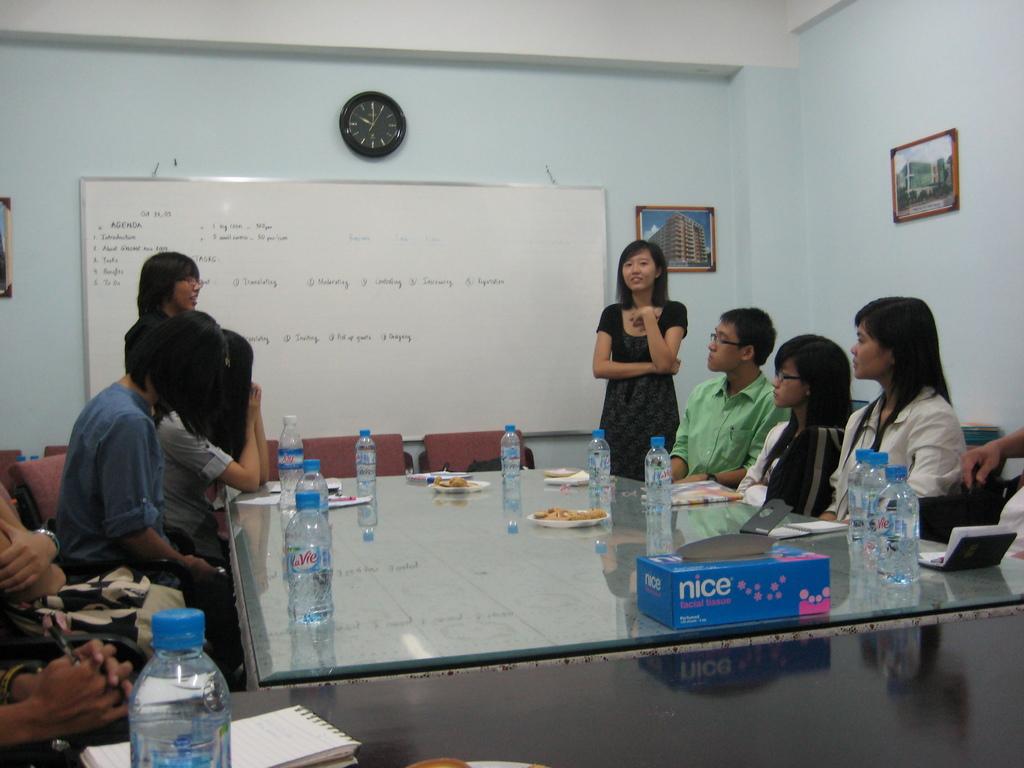What brand of tissue is on the table?
Offer a very short reply. Nice. What word is on the foreground box?
Provide a short and direct response. Nice. 